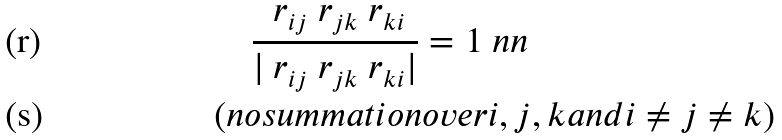<formula> <loc_0><loc_0><loc_500><loc_500>& \quad \frac { \ r _ { i j } \ r _ { j k } \ r _ { k i } } { | \ r _ { i j } \ r _ { j k } \ r _ { k i } | } = 1 \ n n \\ & ( n o s u m m a t i o n o v e r i , j , k a n d i \neq j \neq k )</formula> 